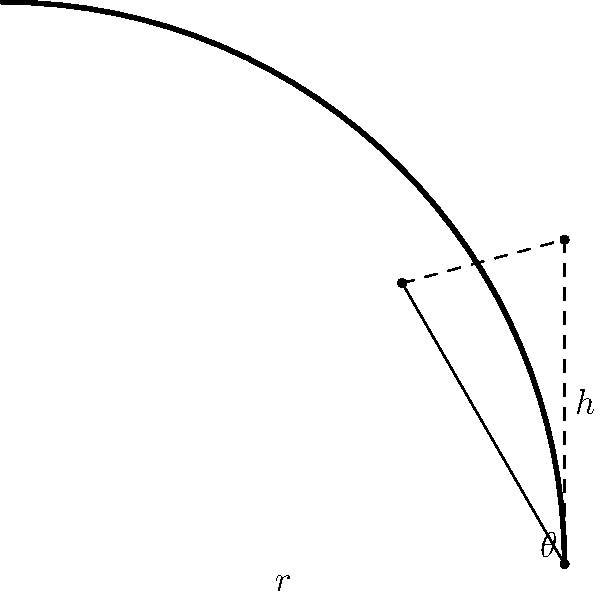During a high-speed descent in the Tour de France, a Team Slipstream cyclist approaches a curved section of road with a radius of 50 meters. To safely navigate the curve at a speed of 54 km/h (15 m/s), what angle of lean (θ) should the cyclist adopt? Assume standard gravity (g = 9.8 m/s²) and neglect air resistance and tire friction. To solve this problem, we'll use the formula for the angle of lean required to balance the centrifugal force in a turn:

$$\tan(\theta) = \frac{v^2}{rg}$$

Where:
- $\theta$ is the angle of lean
- $v$ is the velocity
- $r$ is the radius of the curve
- $g$ is the acceleration due to gravity

Step 1: Convert given values to SI units
- Radius (r) = 50 m
- Velocity (v) = 15 m/s
- Gravity (g) = 9.8 m/s²

Step 2: Substitute the values into the formula
$$\tan(\theta) = \frac{15^2}{50 \times 9.8}$$

Step 3: Calculate the right-hand side
$$\tan(\theta) = \frac{225}{490} \approx 0.4592$$

Step 4: Take the inverse tangent (arctan) of both sides to solve for θ
$$\theta = \arctan(0.4592)$$

Step 5: Calculate the final result
$$\theta \approx 24.65°$$

Therefore, the cyclist should lean at an angle of approximately 24.65 degrees to safely navigate the curve.
Answer: 24.65° 